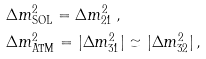<formula> <loc_0><loc_0><loc_500><loc_500>& \Delta { m } ^ { 2 } _ { \text {SOL} } = \Delta { m } ^ { 2 } _ { 2 1 } \, , \\ & \Delta { m } ^ { 2 } _ { \text {ATM} } = | \Delta { m } ^ { 2 } _ { 3 1 } | \simeq | \Delta { m } ^ { 2 } _ { 3 2 } | \, ,</formula> 